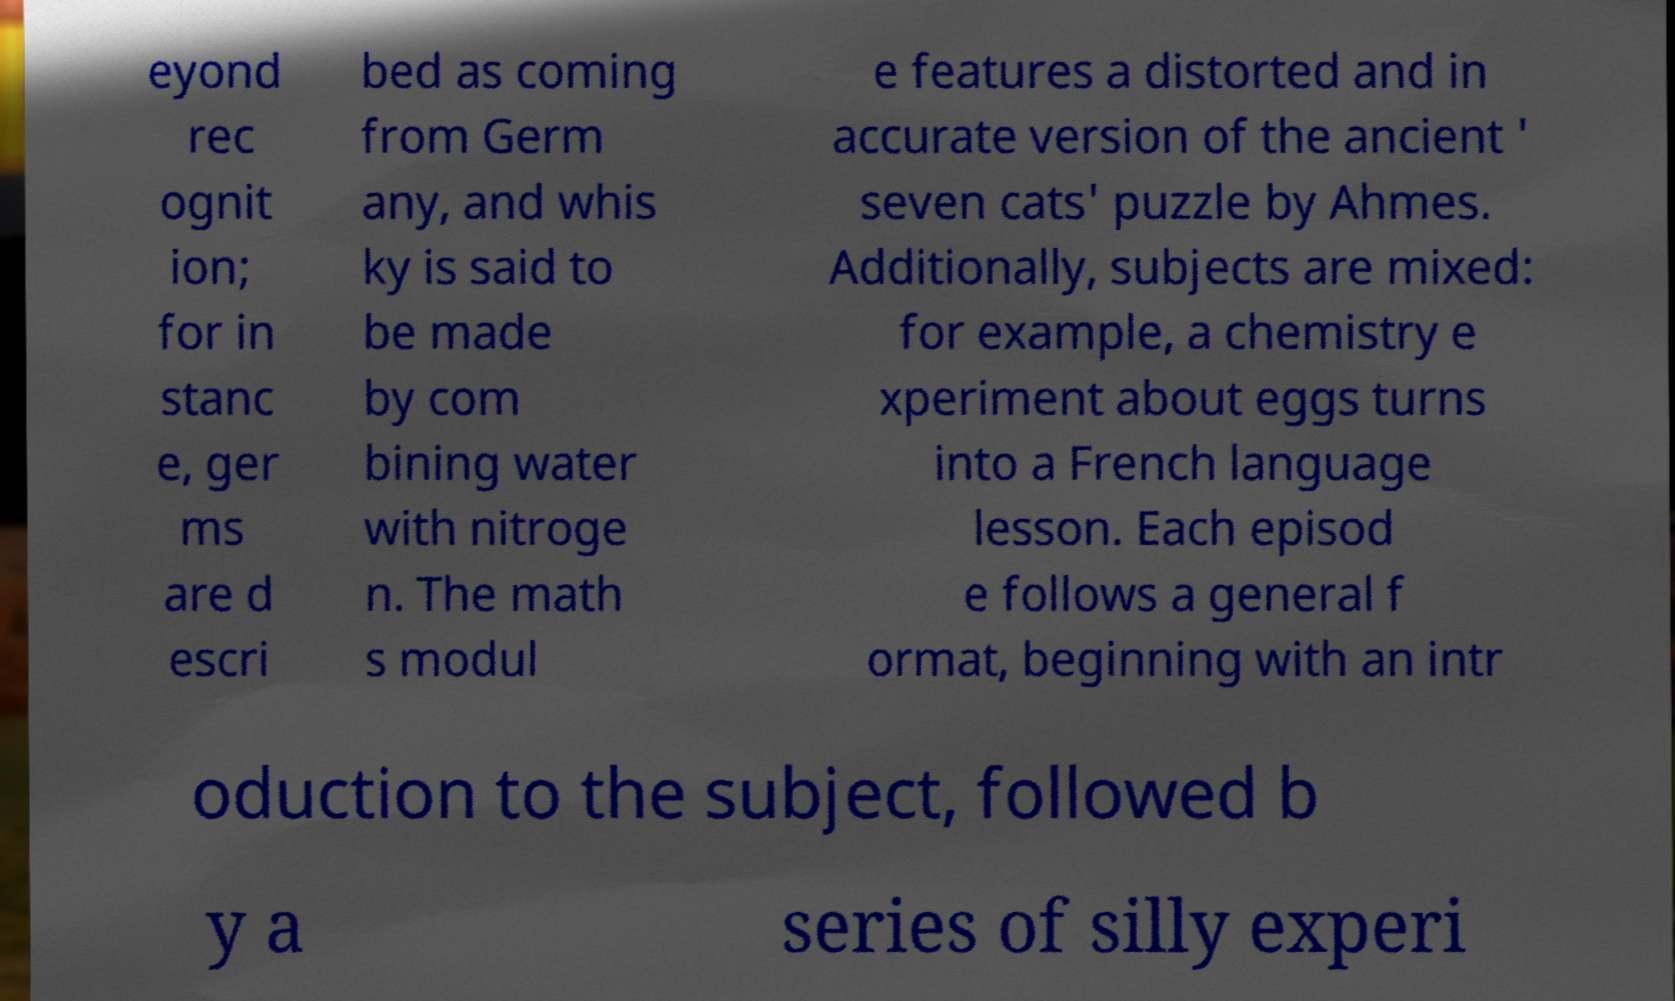Can you accurately transcribe the text from the provided image for me? eyond rec ognit ion; for in stanc e, ger ms are d escri bed as coming from Germ any, and whis ky is said to be made by com bining water with nitroge n. The math s modul e features a distorted and in accurate version of the ancient ' seven cats' puzzle by Ahmes. Additionally, subjects are mixed: for example, a chemistry e xperiment about eggs turns into a French language lesson. Each episod e follows a general f ormat, beginning with an intr oduction to the subject, followed b y a series of silly experi 